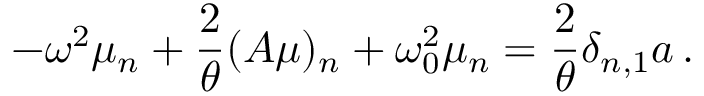<formula> <loc_0><loc_0><loc_500><loc_500>- \omega ^ { 2 } \mu _ { n } + \frac { 2 } { \theta } ( A \mu ) _ { n } + \omega _ { 0 } ^ { 2 } \mu _ { n } = \frac { 2 } { \theta } \delta _ { n , 1 } a \, .</formula> 